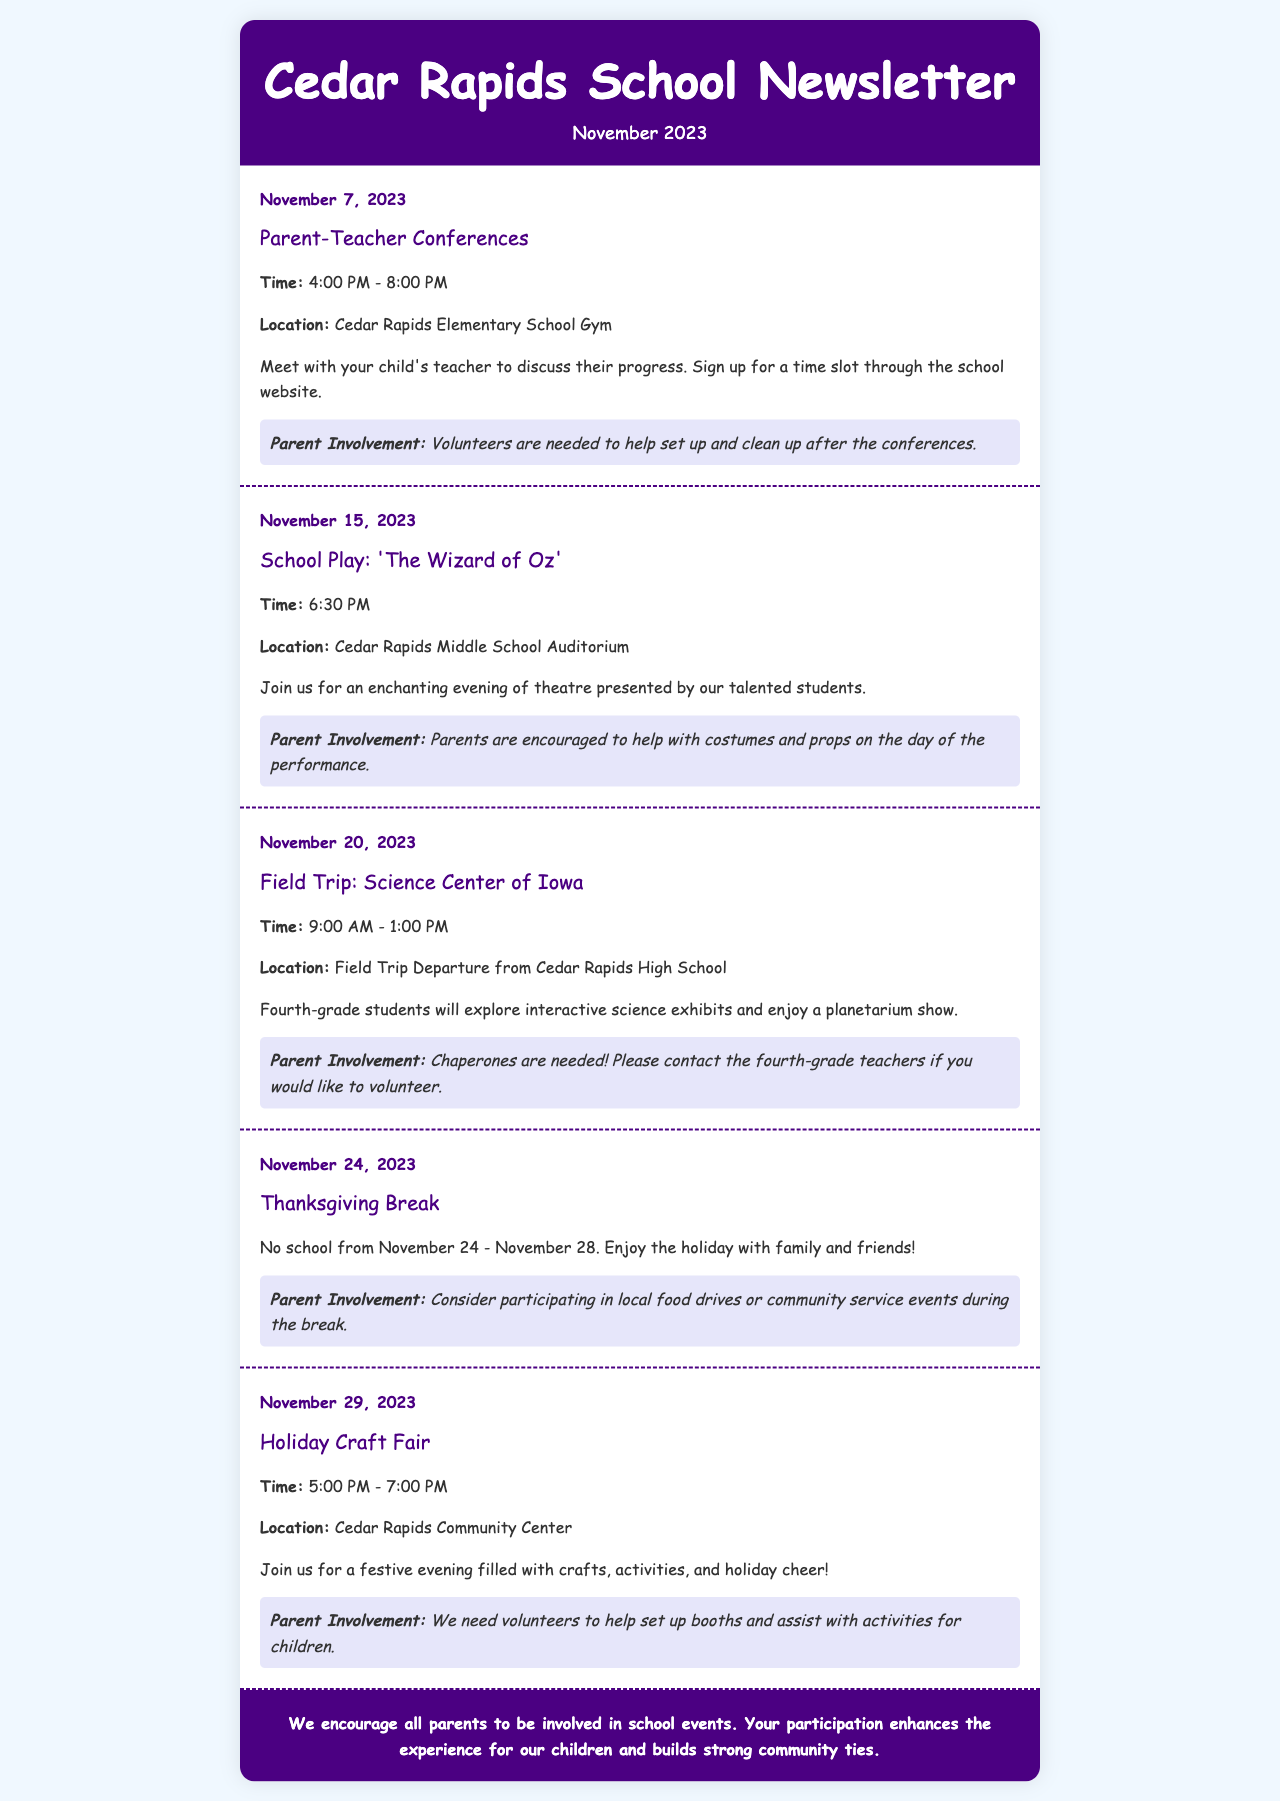What date are the Parent-Teacher Conferences? The date is explicitly mentioned in the document as November 7, 2023.
Answer: November 7, 2023 What time does the School Play start? The document states the starting time for the School Play is 6:30 PM.
Answer: 6:30 PM Where is the Holiday Craft Fair taking place? The location for the Holiday Craft Fair is specified as Cedar Rapids Community Center.
Answer: Cedar Rapids Community Center How long is the Thanksgiving Break? The document indicates the break lasts from November 24 to November 28, which is 5 days.
Answer: 5 days What involvement is needed for the field trip to the Science Center of Iowa? The document requests chaperones for the field trip as noted in the parent involvement section.
Answer: Chaperones What is the main purpose of Parent-Teacher Conferences? The purpose is to meet with the child's teacher to discuss their progress.
Answer: Discuss their progress What type of event is scheduled for November 15, 2023? The type of event mentioned for that date is a school play titled 'The Wizard of Oz'.
Answer: School Play Which event encourages participation in local food drives? This encouragement is noted during the Thanksgiving Break section of the newsletter.
Answer: Thanksgiving Break When are parents encouraged to help with costumes and props? The document specifies that help is needed on the day of the performance for the School Play.
Answer: Day of the performance 